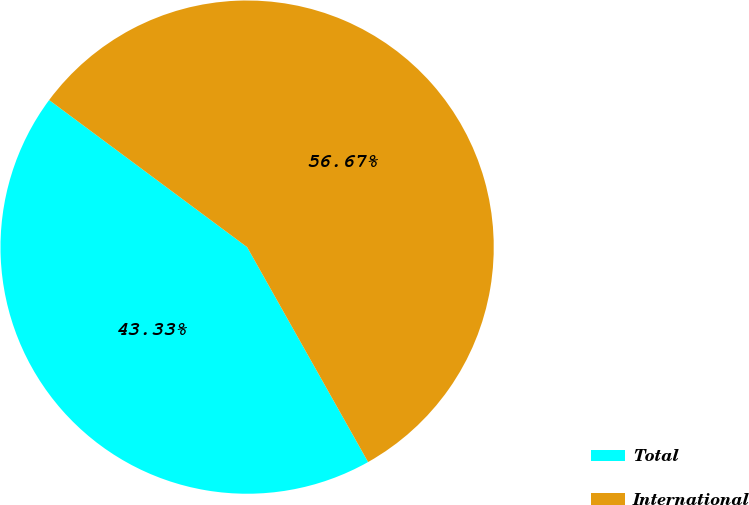<chart> <loc_0><loc_0><loc_500><loc_500><pie_chart><fcel>Total<fcel>International<nl><fcel>43.33%<fcel>56.67%<nl></chart> 